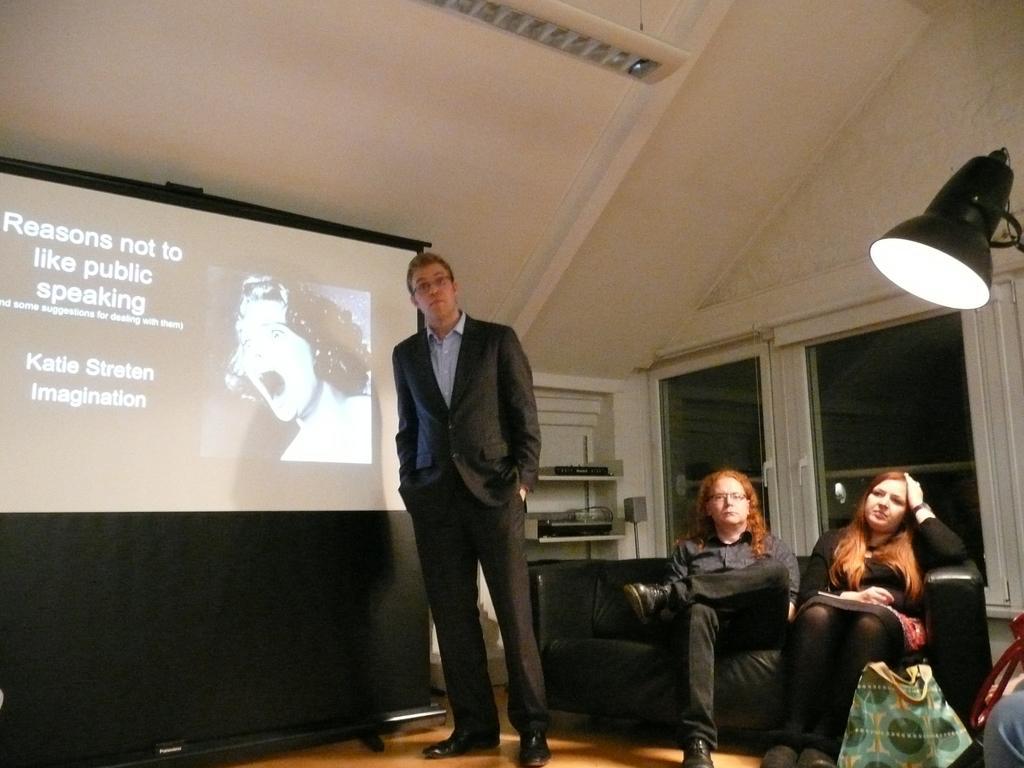Could you give a brief overview of what you see in this image? In this image I can see three people with different color dresses. I can see two people sitting on the couch and one person standing to the side of the screen. To the right I can see some bags. In the background I can see some electronic gadgets, glass doors and the light. 